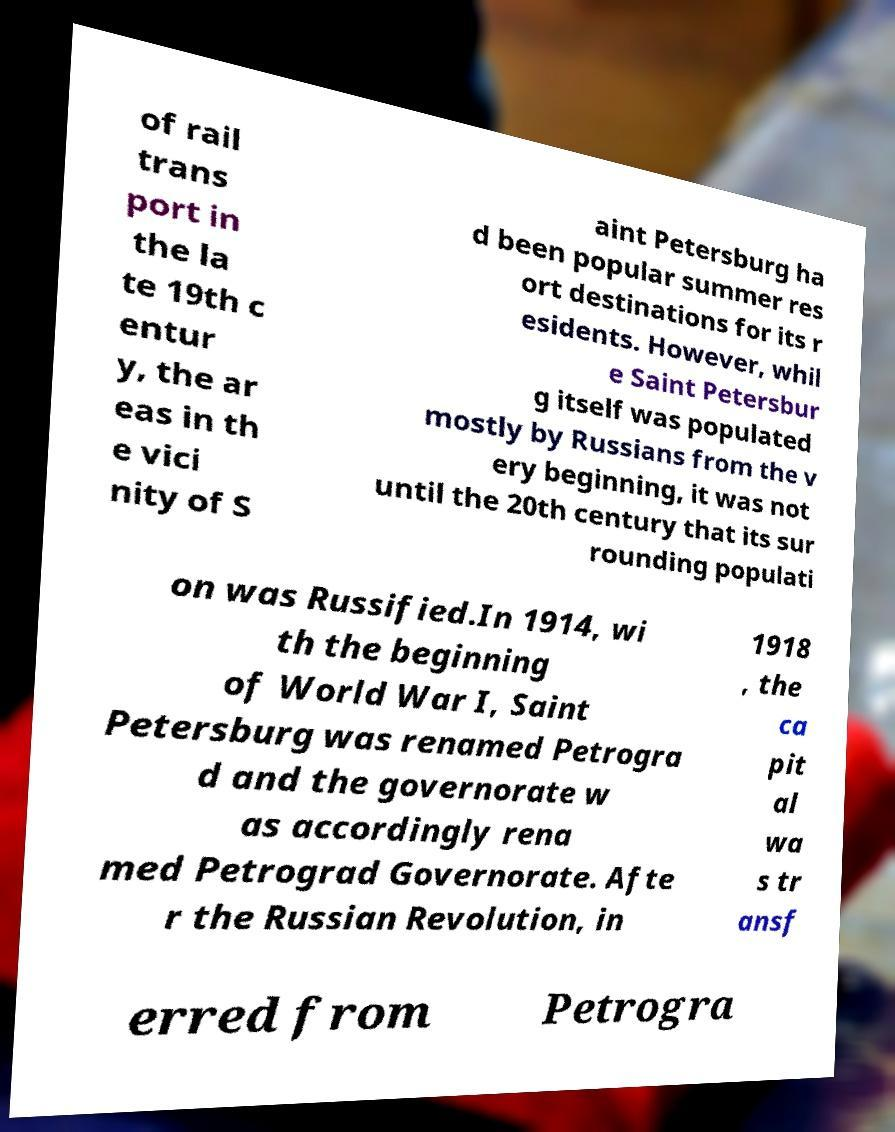Could you extract and type out the text from this image? of rail trans port in the la te 19th c entur y, the ar eas in th e vici nity of S aint Petersburg ha d been popular summer res ort destinations for its r esidents. However, whil e Saint Petersbur g itself was populated mostly by Russians from the v ery beginning, it was not until the 20th century that its sur rounding populati on was Russified.In 1914, wi th the beginning of World War I, Saint Petersburg was renamed Petrogra d and the governorate w as accordingly rena med Petrograd Governorate. Afte r the Russian Revolution, in 1918 , the ca pit al wa s tr ansf erred from Petrogra 